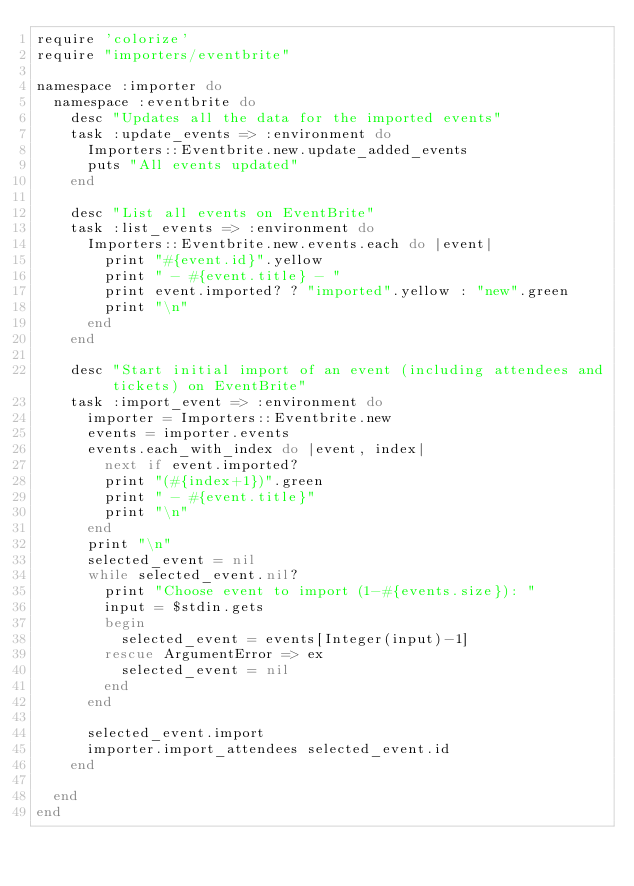<code> <loc_0><loc_0><loc_500><loc_500><_Ruby_>require 'colorize'
require "importers/eventbrite"

namespace :importer do
  namespace :eventbrite do
    desc "Updates all the data for the imported events"
    task :update_events => :environment do
      Importers::Eventbrite.new.update_added_events
      puts "All events updated"
    end

    desc "List all events on EventBrite"
    task :list_events => :environment do
      Importers::Eventbrite.new.events.each do |event|
        print "#{event.id}".yellow
        print " - #{event.title} - "
        print event.imported? ? "imported".yellow : "new".green
        print "\n"
      end
    end

    desc "Start initial import of an event (including attendees and tickets) on EventBrite"
    task :import_event => :environment do
      importer = Importers::Eventbrite.new
      events = importer.events
      events.each_with_index do |event, index|
        next if event.imported?
        print "(#{index+1})".green
        print " - #{event.title}"
        print "\n"
      end
      print "\n"
      selected_event = nil
      while selected_event.nil?
        print "Choose event to import (1-#{events.size}): "
        input = $stdin.gets
        begin
          selected_event = events[Integer(input)-1]
        rescue ArgumentError => ex
          selected_event = nil
        end
      end

      selected_event.import
      importer.import_attendees selected_event.id
    end

  end
end</code> 